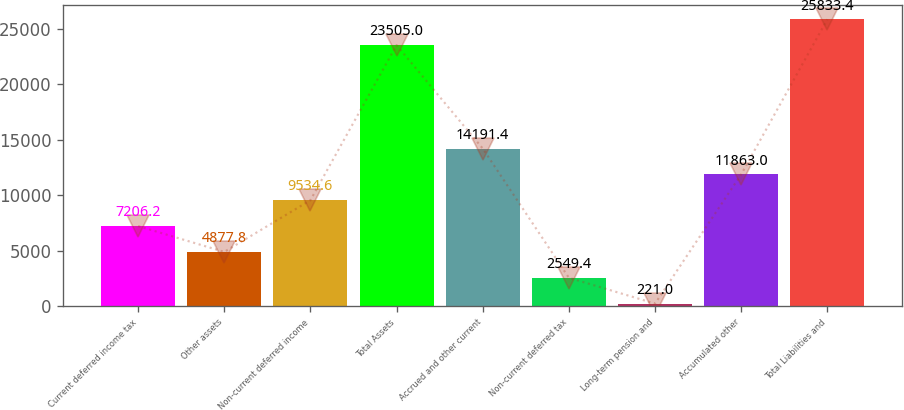Convert chart to OTSL. <chart><loc_0><loc_0><loc_500><loc_500><bar_chart><fcel>Current deferred income tax<fcel>Other assets<fcel>Non-current deferred income<fcel>Total Assets<fcel>Accrued and other current<fcel>Non-current deferred tax<fcel>Long-term pension and<fcel>Accumulated other<fcel>Total Liabilities and<nl><fcel>7206.2<fcel>4877.8<fcel>9534.6<fcel>23505<fcel>14191.4<fcel>2549.4<fcel>221<fcel>11863<fcel>25833.4<nl></chart> 